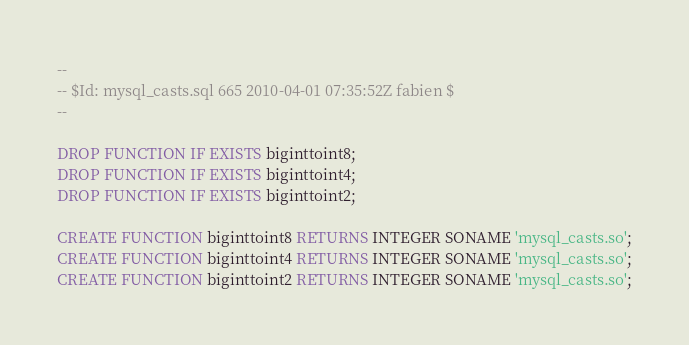<code> <loc_0><loc_0><loc_500><loc_500><_SQL_>--
-- $Id: mysql_casts.sql 665 2010-04-01 07:35:52Z fabien $
--

DROP FUNCTION IF EXISTS biginttoint8;
DROP FUNCTION IF EXISTS biginttoint4;
DROP FUNCTION IF EXISTS biginttoint2;

CREATE FUNCTION biginttoint8 RETURNS INTEGER SONAME 'mysql_casts.so';
CREATE FUNCTION biginttoint4 RETURNS INTEGER SONAME 'mysql_casts.so';
CREATE FUNCTION biginttoint2 RETURNS INTEGER SONAME 'mysql_casts.so';
</code> 